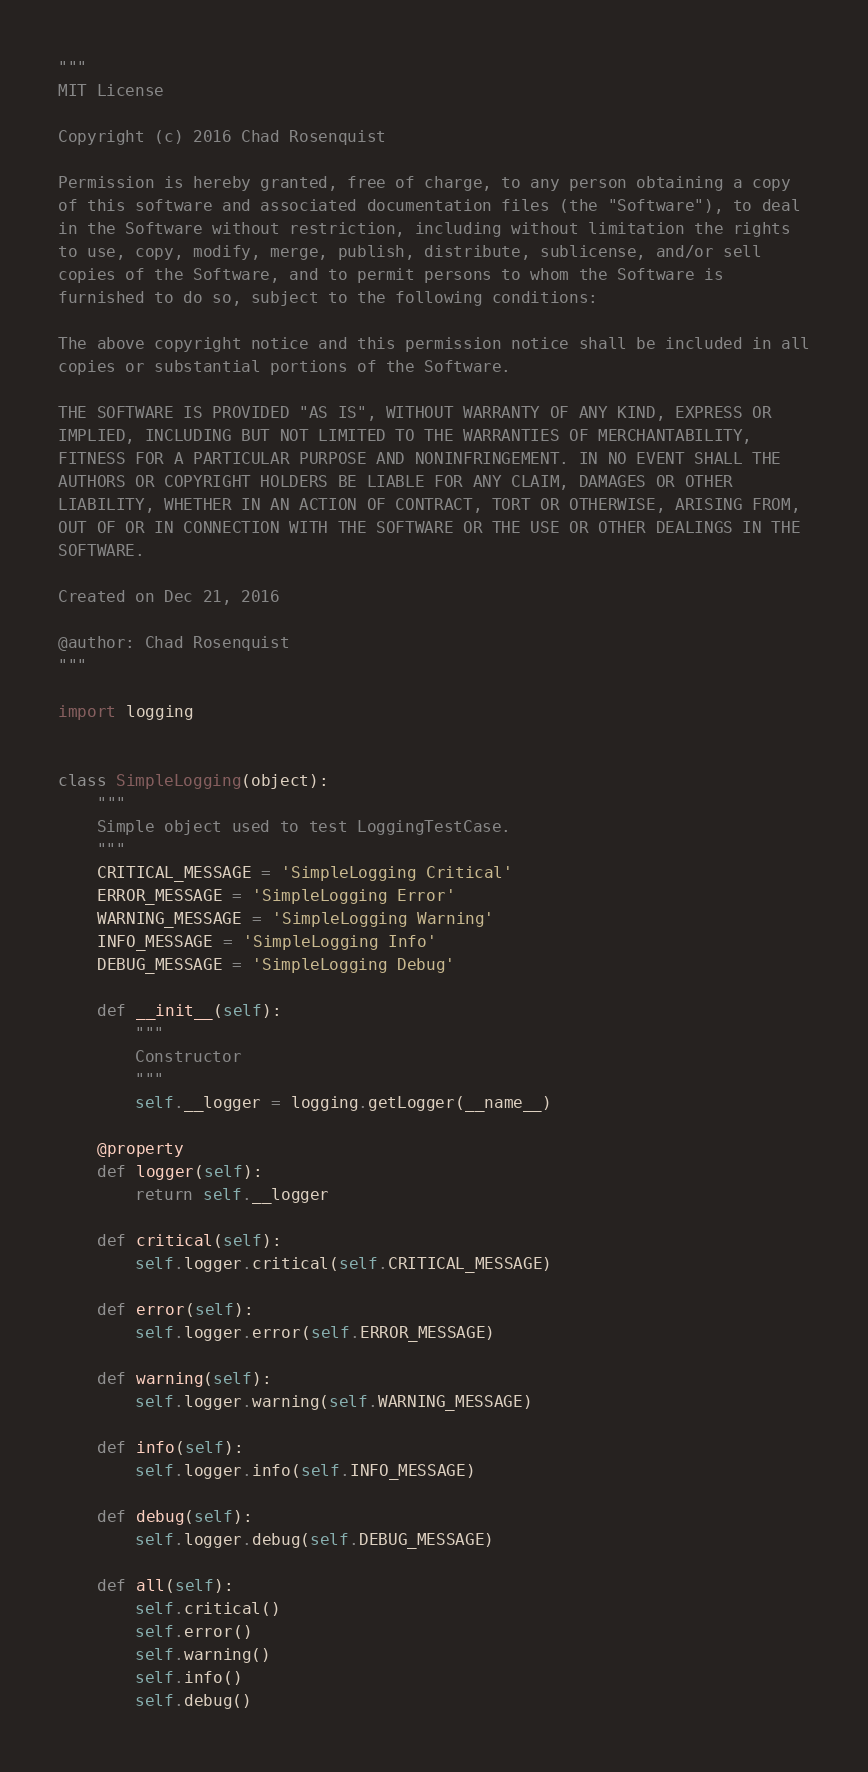Convert code to text. <code><loc_0><loc_0><loc_500><loc_500><_Python_>"""
MIT License

Copyright (c) 2016 Chad Rosenquist

Permission is hereby granted, free of charge, to any person obtaining a copy
of this software and associated documentation files (the "Software"), to deal
in the Software without restriction, including without limitation the rights
to use, copy, modify, merge, publish, distribute, sublicense, and/or sell
copies of the Software, and to permit persons to whom the Software is
furnished to do so, subject to the following conditions:

The above copyright notice and this permission notice shall be included in all
copies or substantial portions of the Software.

THE SOFTWARE IS PROVIDED "AS IS", WITHOUT WARRANTY OF ANY KIND, EXPRESS OR
IMPLIED, INCLUDING BUT NOT LIMITED TO THE WARRANTIES OF MERCHANTABILITY,
FITNESS FOR A PARTICULAR PURPOSE AND NONINFRINGEMENT. IN NO EVENT SHALL THE
AUTHORS OR COPYRIGHT HOLDERS BE LIABLE FOR ANY CLAIM, DAMAGES OR OTHER
LIABILITY, WHETHER IN AN ACTION OF CONTRACT, TORT OR OTHERWISE, ARISING FROM,
OUT OF OR IN CONNECTION WITH THE SOFTWARE OR THE USE OR OTHER DEALINGS IN THE
SOFTWARE.

Created on Dec 21, 2016

@author: Chad Rosenquist
"""

import logging


class SimpleLogging(object):
    """
    Simple object used to test LoggingTestCase.
    """
    CRITICAL_MESSAGE = 'SimpleLogging Critical'
    ERROR_MESSAGE = 'SimpleLogging Error'
    WARNING_MESSAGE = 'SimpleLogging Warning'
    INFO_MESSAGE = 'SimpleLogging Info'
    DEBUG_MESSAGE = 'SimpleLogging Debug'

    def __init__(self):
        """
        Constructor
        """
        self.__logger = logging.getLogger(__name__)

    @property
    def logger(self):
        return self.__logger
    
    def critical(self):
        self.logger.critical(self.CRITICAL_MESSAGE)
    
    def error(self):
        self.logger.error(self.ERROR_MESSAGE)
    
    def warning(self):
        self.logger.warning(self.WARNING_MESSAGE)
    
    def info(self):
        self.logger.info(self.INFO_MESSAGE)
    
    def debug(self):
        self.logger.debug(self.DEBUG_MESSAGE)

    def all(self):
        self.critical()
        self.error()
        self.warning()
        self.info()
        self.debug()
</code> 